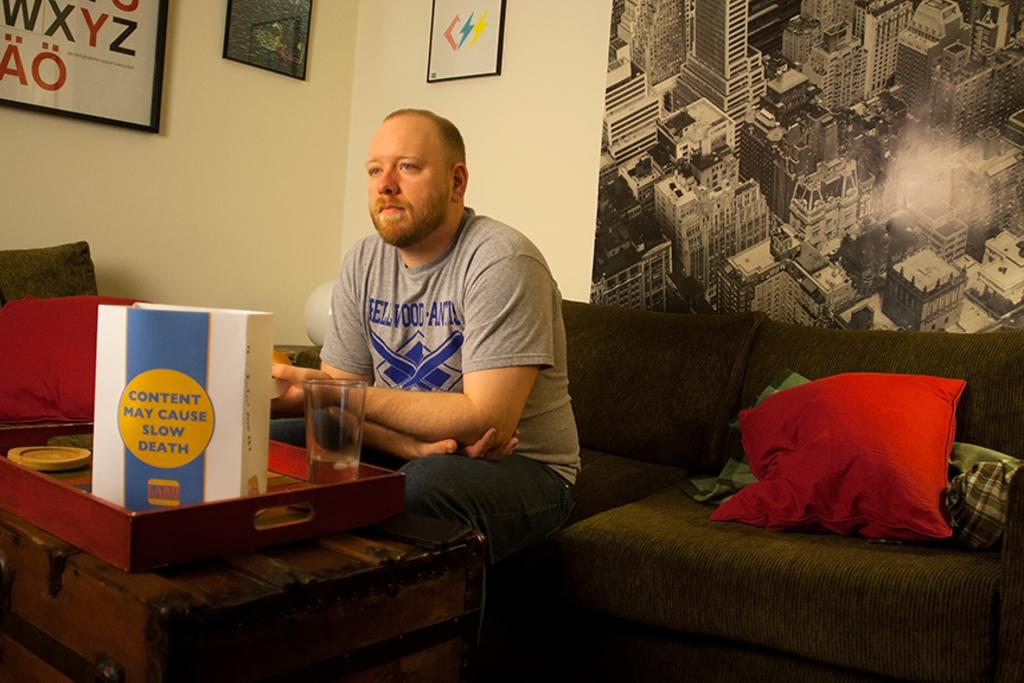What type of structure can be seen in the image? There is a wall in the image. What decorative item is present on the wall? There is a photo frame in the image. What additional item is hanging on the wall? There is a banner in the image. What is the man in the image doing? The man is sitting on a sofa in the image. What type of soft furnishings can be seen in the image? There are pillows in the image. How many rabbits are playing on the sofa with the man in the image? There are no rabbits present in the image; only the man and the pillows can be seen on the sofa. What type of recess is visible in the image? There is no recess visible in the image; the focus is on the wall, the man, and the sofa. 